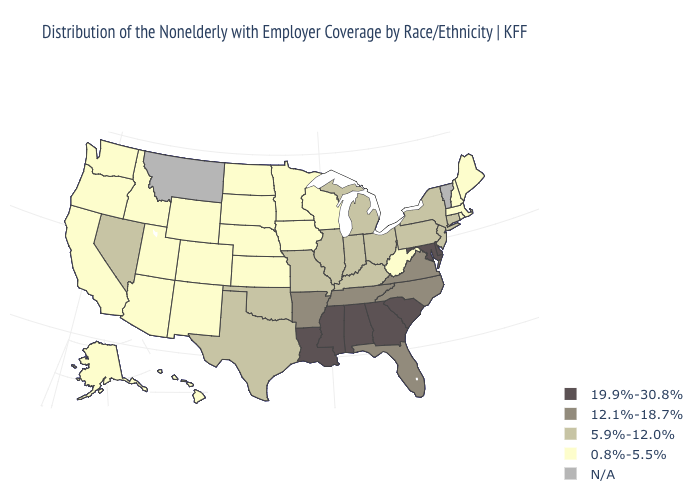Among the states that border Montana , which have the highest value?
Keep it brief. Idaho, North Dakota, South Dakota, Wyoming. Which states have the lowest value in the MidWest?
Keep it brief. Iowa, Kansas, Minnesota, Nebraska, North Dakota, South Dakota, Wisconsin. Name the states that have a value in the range 12.1%-18.7%?
Give a very brief answer. Arkansas, Florida, North Carolina, Tennessee, Virginia. Does the first symbol in the legend represent the smallest category?
Quick response, please. No. Does Idaho have the highest value in the USA?
Answer briefly. No. Is the legend a continuous bar?
Keep it brief. No. Does the first symbol in the legend represent the smallest category?
Keep it brief. No. Name the states that have a value in the range 0.8%-5.5%?
Be succinct. Alaska, Arizona, California, Colorado, Hawaii, Idaho, Iowa, Kansas, Maine, Massachusetts, Minnesota, Nebraska, New Hampshire, New Mexico, North Dakota, Oregon, Rhode Island, South Dakota, Utah, Washington, West Virginia, Wisconsin, Wyoming. Among the states that border Ohio , which have the highest value?
Concise answer only. Indiana, Kentucky, Michigan, Pennsylvania. What is the lowest value in the Northeast?
Short answer required. 0.8%-5.5%. Does Pennsylvania have the highest value in the Northeast?
Answer briefly. Yes. Does the map have missing data?
Quick response, please. Yes. Name the states that have a value in the range 5.9%-12.0%?
Give a very brief answer. Connecticut, Illinois, Indiana, Kentucky, Michigan, Missouri, Nevada, New Jersey, New York, Ohio, Oklahoma, Pennsylvania, Texas. What is the value of Oregon?
Be succinct. 0.8%-5.5%. 